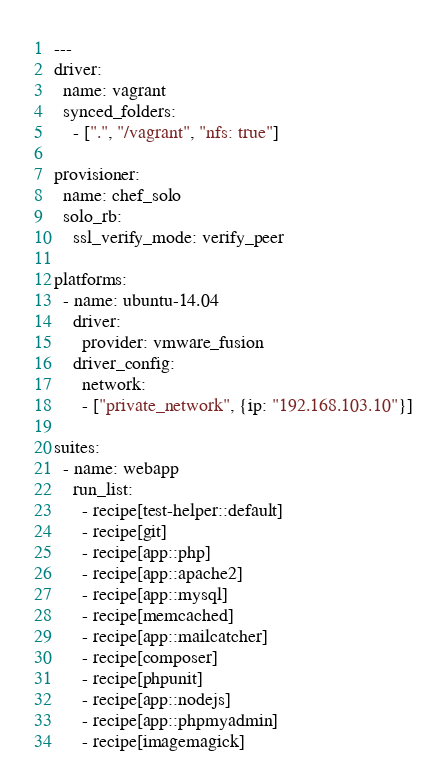Convert code to text. <code><loc_0><loc_0><loc_500><loc_500><_YAML_>---
driver:
  name: vagrant
  synced_folders:
    - [".", "/vagrant", "nfs: true"]

provisioner:
  name: chef_solo
  solo_rb:
    ssl_verify_mode: verify_peer

platforms:
  - name: ubuntu-14.04
    driver:
      provider: vmware_fusion
    driver_config:
      network:
      - ["private_network", {ip: "192.168.103.10"}]

suites:
  - name: webapp
    run_list:
      - recipe[test-helper::default]
      - recipe[git]
      - recipe[app::php]
      - recipe[app::apache2]
      - recipe[app::mysql]
      - recipe[memcached]
      - recipe[app::mailcatcher]
      - recipe[composer]
      - recipe[phpunit]
      - recipe[app::nodejs]
      - recipe[app::phpmyadmin]
      - recipe[imagemagick]
</code> 